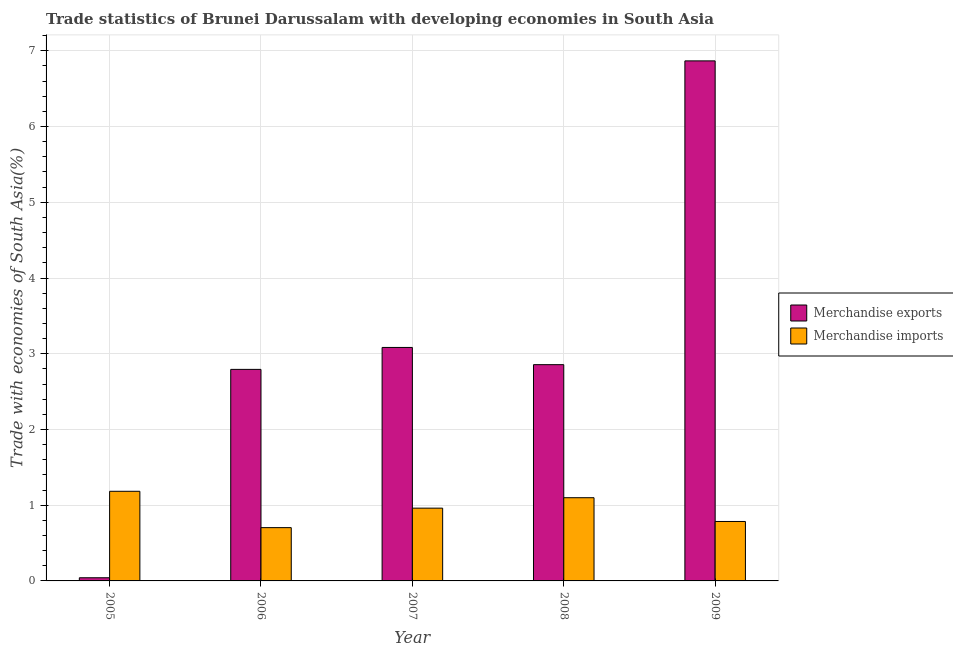How many different coloured bars are there?
Keep it short and to the point. 2. How many groups of bars are there?
Offer a terse response. 5. Are the number of bars per tick equal to the number of legend labels?
Offer a terse response. Yes. How many bars are there on the 5th tick from the left?
Offer a very short reply. 2. How many bars are there on the 2nd tick from the right?
Offer a very short reply. 2. In how many cases, is the number of bars for a given year not equal to the number of legend labels?
Make the answer very short. 0. What is the merchandise exports in 2007?
Offer a very short reply. 3.08. Across all years, what is the maximum merchandise exports?
Give a very brief answer. 6.87. Across all years, what is the minimum merchandise exports?
Provide a short and direct response. 0.04. In which year was the merchandise imports maximum?
Make the answer very short. 2005. What is the total merchandise imports in the graph?
Provide a short and direct response. 4.73. What is the difference between the merchandise imports in 2005 and that in 2009?
Make the answer very short. 0.4. What is the difference between the merchandise exports in 2006 and the merchandise imports in 2007?
Give a very brief answer. -0.29. What is the average merchandise imports per year?
Offer a very short reply. 0.95. In the year 2005, what is the difference between the merchandise exports and merchandise imports?
Provide a succinct answer. 0. What is the ratio of the merchandise exports in 2007 to that in 2008?
Your answer should be very brief. 1.08. Is the difference between the merchandise exports in 2008 and 2009 greater than the difference between the merchandise imports in 2008 and 2009?
Ensure brevity in your answer.  No. What is the difference between the highest and the second highest merchandise imports?
Your answer should be compact. 0.08. What is the difference between the highest and the lowest merchandise imports?
Provide a short and direct response. 0.48. What does the 1st bar from the right in 2008 represents?
Provide a succinct answer. Merchandise imports. How many bars are there?
Your answer should be very brief. 10. Are all the bars in the graph horizontal?
Provide a succinct answer. No. What is the difference between two consecutive major ticks on the Y-axis?
Your response must be concise. 1. Does the graph contain any zero values?
Your answer should be compact. No. How many legend labels are there?
Your answer should be compact. 2. How are the legend labels stacked?
Your answer should be very brief. Vertical. What is the title of the graph?
Give a very brief answer. Trade statistics of Brunei Darussalam with developing economies in South Asia. What is the label or title of the X-axis?
Provide a succinct answer. Year. What is the label or title of the Y-axis?
Ensure brevity in your answer.  Trade with economies of South Asia(%). What is the Trade with economies of South Asia(%) in Merchandise exports in 2005?
Make the answer very short. 0.04. What is the Trade with economies of South Asia(%) in Merchandise imports in 2005?
Provide a short and direct response. 1.18. What is the Trade with economies of South Asia(%) of Merchandise exports in 2006?
Offer a terse response. 2.79. What is the Trade with economies of South Asia(%) of Merchandise imports in 2006?
Provide a short and direct response. 0.7. What is the Trade with economies of South Asia(%) of Merchandise exports in 2007?
Give a very brief answer. 3.08. What is the Trade with economies of South Asia(%) in Merchandise imports in 2007?
Your answer should be very brief. 0.96. What is the Trade with economies of South Asia(%) in Merchandise exports in 2008?
Offer a very short reply. 2.86. What is the Trade with economies of South Asia(%) in Merchandise imports in 2008?
Make the answer very short. 1.1. What is the Trade with economies of South Asia(%) in Merchandise exports in 2009?
Keep it short and to the point. 6.87. What is the Trade with economies of South Asia(%) in Merchandise imports in 2009?
Your answer should be very brief. 0.78. Across all years, what is the maximum Trade with economies of South Asia(%) of Merchandise exports?
Offer a very short reply. 6.87. Across all years, what is the maximum Trade with economies of South Asia(%) of Merchandise imports?
Offer a very short reply. 1.18. Across all years, what is the minimum Trade with economies of South Asia(%) of Merchandise exports?
Give a very brief answer. 0.04. Across all years, what is the minimum Trade with economies of South Asia(%) in Merchandise imports?
Offer a very short reply. 0.7. What is the total Trade with economies of South Asia(%) in Merchandise exports in the graph?
Provide a succinct answer. 15.64. What is the total Trade with economies of South Asia(%) of Merchandise imports in the graph?
Keep it short and to the point. 4.73. What is the difference between the Trade with economies of South Asia(%) of Merchandise exports in 2005 and that in 2006?
Make the answer very short. -2.75. What is the difference between the Trade with economies of South Asia(%) of Merchandise imports in 2005 and that in 2006?
Make the answer very short. 0.48. What is the difference between the Trade with economies of South Asia(%) in Merchandise exports in 2005 and that in 2007?
Your answer should be compact. -3.04. What is the difference between the Trade with economies of South Asia(%) of Merchandise imports in 2005 and that in 2007?
Keep it short and to the point. 0.22. What is the difference between the Trade with economies of South Asia(%) of Merchandise exports in 2005 and that in 2008?
Offer a terse response. -2.81. What is the difference between the Trade with economies of South Asia(%) of Merchandise imports in 2005 and that in 2008?
Your answer should be compact. 0.08. What is the difference between the Trade with economies of South Asia(%) in Merchandise exports in 2005 and that in 2009?
Your answer should be very brief. -6.83. What is the difference between the Trade with economies of South Asia(%) of Merchandise imports in 2005 and that in 2009?
Your answer should be compact. 0.4. What is the difference between the Trade with economies of South Asia(%) in Merchandise exports in 2006 and that in 2007?
Offer a very short reply. -0.29. What is the difference between the Trade with economies of South Asia(%) in Merchandise imports in 2006 and that in 2007?
Provide a short and direct response. -0.26. What is the difference between the Trade with economies of South Asia(%) in Merchandise exports in 2006 and that in 2008?
Provide a succinct answer. -0.06. What is the difference between the Trade with economies of South Asia(%) in Merchandise imports in 2006 and that in 2008?
Provide a succinct answer. -0.4. What is the difference between the Trade with economies of South Asia(%) in Merchandise exports in 2006 and that in 2009?
Offer a terse response. -4.07. What is the difference between the Trade with economies of South Asia(%) of Merchandise imports in 2006 and that in 2009?
Keep it short and to the point. -0.08. What is the difference between the Trade with economies of South Asia(%) in Merchandise exports in 2007 and that in 2008?
Give a very brief answer. 0.23. What is the difference between the Trade with economies of South Asia(%) in Merchandise imports in 2007 and that in 2008?
Provide a succinct answer. -0.14. What is the difference between the Trade with economies of South Asia(%) in Merchandise exports in 2007 and that in 2009?
Offer a terse response. -3.78. What is the difference between the Trade with economies of South Asia(%) of Merchandise imports in 2007 and that in 2009?
Your answer should be compact. 0.18. What is the difference between the Trade with economies of South Asia(%) of Merchandise exports in 2008 and that in 2009?
Provide a succinct answer. -4.01. What is the difference between the Trade with economies of South Asia(%) in Merchandise imports in 2008 and that in 2009?
Ensure brevity in your answer.  0.31. What is the difference between the Trade with economies of South Asia(%) of Merchandise exports in 2005 and the Trade with economies of South Asia(%) of Merchandise imports in 2006?
Your answer should be compact. -0.66. What is the difference between the Trade with economies of South Asia(%) of Merchandise exports in 2005 and the Trade with economies of South Asia(%) of Merchandise imports in 2007?
Keep it short and to the point. -0.92. What is the difference between the Trade with economies of South Asia(%) in Merchandise exports in 2005 and the Trade with economies of South Asia(%) in Merchandise imports in 2008?
Ensure brevity in your answer.  -1.06. What is the difference between the Trade with economies of South Asia(%) in Merchandise exports in 2005 and the Trade with economies of South Asia(%) in Merchandise imports in 2009?
Your answer should be compact. -0.74. What is the difference between the Trade with economies of South Asia(%) in Merchandise exports in 2006 and the Trade with economies of South Asia(%) in Merchandise imports in 2007?
Your answer should be very brief. 1.83. What is the difference between the Trade with economies of South Asia(%) in Merchandise exports in 2006 and the Trade with economies of South Asia(%) in Merchandise imports in 2008?
Keep it short and to the point. 1.69. What is the difference between the Trade with economies of South Asia(%) in Merchandise exports in 2006 and the Trade with economies of South Asia(%) in Merchandise imports in 2009?
Offer a terse response. 2.01. What is the difference between the Trade with economies of South Asia(%) of Merchandise exports in 2007 and the Trade with economies of South Asia(%) of Merchandise imports in 2008?
Provide a succinct answer. 1.98. What is the difference between the Trade with economies of South Asia(%) in Merchandise exports in 2007 and the Trade with economies of South Asia(%) in Merchandise imports in 2009?
Your answer should be compact. 2.3. What is the difference between the Trade with economies of South Asia(%) in Merchandise exports in 2008 and the Trade with economies of South Asia(%) in Merchandise imports in 2009?
Your answer should be very brief. 2.07. What is the average Trade with economies of South Asia(%) in Merchandise exports per year?
Your answer should be very brief. 3.13. What is the average Trade with economies of South Asia(%) in Merchandise imports per year?
Provide a short and direct response. 0.95. In the year 2005, what is the difference between the Trade with economies of South Asia(%) in Merchandise exports and Trade with economies of South Asia(%) in Merchandise imports?
Provide a succinct answer. -1.14. In the year 2006, what is the difference between the Trade with economies of South Asia(%) in Merchandise exports and Trade with economies of South Asia(%) in Merchandise imports?
Your response must be concise. 2.09. In the year 2007, what is the difference between the Trade with economies of South Asia(%) in Merchandise exports and Trade with economies of South Asia(%) in Merchandise imports?
Your answer should be compact. 2.12. In the year 2008, what is the difference between the Trade with economies of South Asia(%) of Merchandise exports and Trade with economies of South Asia(%) of Merchandise imports?
Offer a very short reply. 1.76. In the year 2009, what is the difference between the Trade with economies of South Asia(%) of Merchandise exports and Trade with economies of South Asia(%) of Merchandise imports?
Your answer should be very brief. 6.08. What is the ratio of the Trade with economies of South Asia(%) in Merchandise exports in 2005 to that in 2006?
Provide a short and direct response. 0.01. What is the ratio of the Trade with economies of South Asia(%) in Merchandise imports in 2005 to that in 2006?
Make the answer very short. 1.68. What is the ratio of the Trade with economies of South Asia(%) in Merchandise exports in 2005 to that in 2007?
Offer a very short reply. 0.01. What is the ratio of the Trade with economies of South Asia(%) of Merchandise imports in 2005 to that in 2007?
Your answer should be very brief. 1.23. What is the ratio of the Trade with economies of South Asia(%) of Merchandise exports in 2005 to that in 2008?
Provide a short and direct response. 0.01. What is the ratio of the Trade with economies of South Asia(%) in Merchandise imports in 2005 to that in 2008?
Offer a very short reply. 1.08. What is the ratio of the Trade with economies of South Asia(%) in Merchandise exports in 2005 to that in 2009?
Your response must be concise. 0.01. What is the ratio of the Trade with economies of South Asia(%) of Merchandise imports in 2005 to that in 2009?
Give a very brief answer. 1.51. What is the ratio of the Trade with economies of South Asia(%) of Merchandise exports in 2006 to that in 2007?
Keep it short and to the point. 0.91. What is the ratio of the Trade with economies of South Asia(%) in Merchandise imports in 2006 to that in 2007?
Your response must be concise. 0.73. What is the ratio of the Trade with economies of South Asia(%) of Merchandise exports in 2006 to that in 2008?
Your answer should be very brief. 0.98. What is the ratio of the Trade with economies of South Asia(%) in Merchandise imports in 2006 to that in 2008?
Make the answer very short. 0.64. What is the ratio of the Trade with economies of South Asia(%) in Merchandise exports in 2006 to that in 2009?
Your answer should be compact. 0.41. What is the ratio of the Trade with economies of South Asia(%) of Merchandise imports in 2006 to that in 2009?
Ensure brevity in your answer.  0.9. What is the ratio of the Trade with economies of South Asia(%) of Merchandise exports in 2007 to that in 2008?
Give a very brief answer. 1.08. What is the ratio of the Trade with economies of South Asia(%) in Merchandise imports in 2007 to that in 2008?
Keep it short and to the point. 0.87. What is the ratio of the Trade with economies of South Asia(%) in Merchandise exports in 2007 to that in 2009?
Give a very brief answer. 0.45. What is the ratio of the Trade with economies of South Asia(%) in Merchandise imports in 2007 to that in 2009?
Provide a succinct answer. 1.22. What is the ratio of the Trade with economies of South Asia(%) in Merchandise exports in 2008 to that in 2009?
Make the answer very short. 0.42. What is the ratio of the Trade with economies of South Asia(%) of Merchandise imports in 2008 to that in 2009?
Your response must be concise. 1.4. What is the difference between the highest and the second highest Trade with economies of South Asia(%) in Merchandise exports?
Provide a short and direct response. 3.78. What is the difference between the highest and the second highest Trade with economies of South Asia(%) of Merchandise imports?
Provide a succinct answer. 0.08. What is the difference between the highest and the lowest Trade with economies of South Asia(%) in Merchandise exports?
Give a very brief answer. 6.83. What is the difference between the highest and the lowest Trade with economies of South Asia(%) in Merchandise imports?
Your response must be concise. 0.48. 